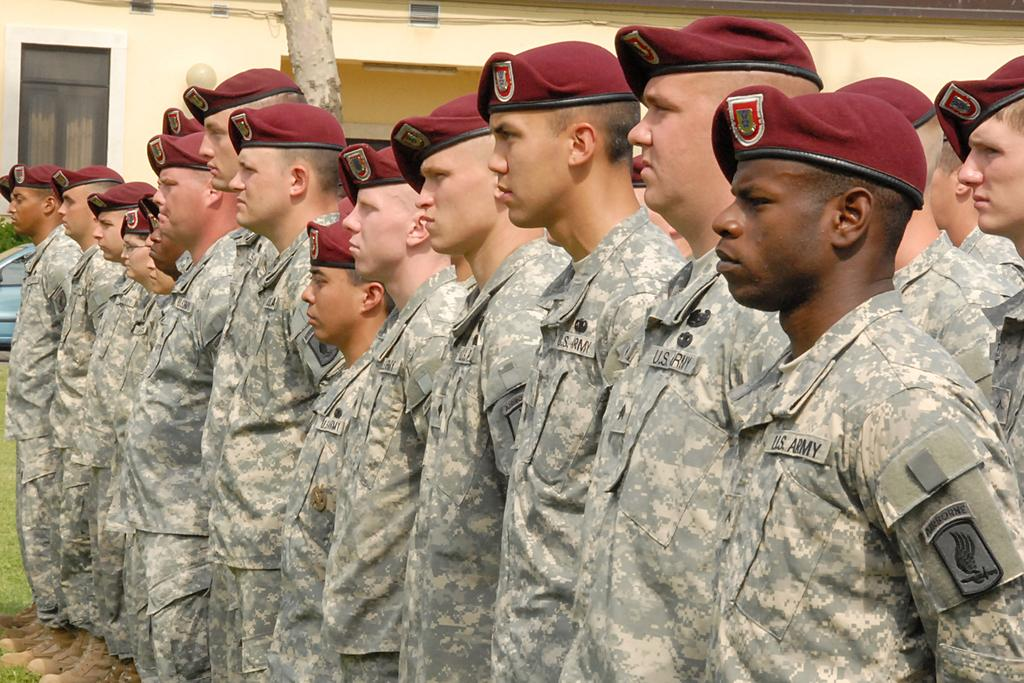What can be seen in the foreground of the image? There are men standing in the foreground of the image. What is the surface the men are standing on? The men are standing on the grass. What is visible in the background of the image? There is a vehicle, a tree trunk, and a building in the background of the image. What is the income of the dog in the image? There is no dog present in the image, so it is not possible to determine its income. 